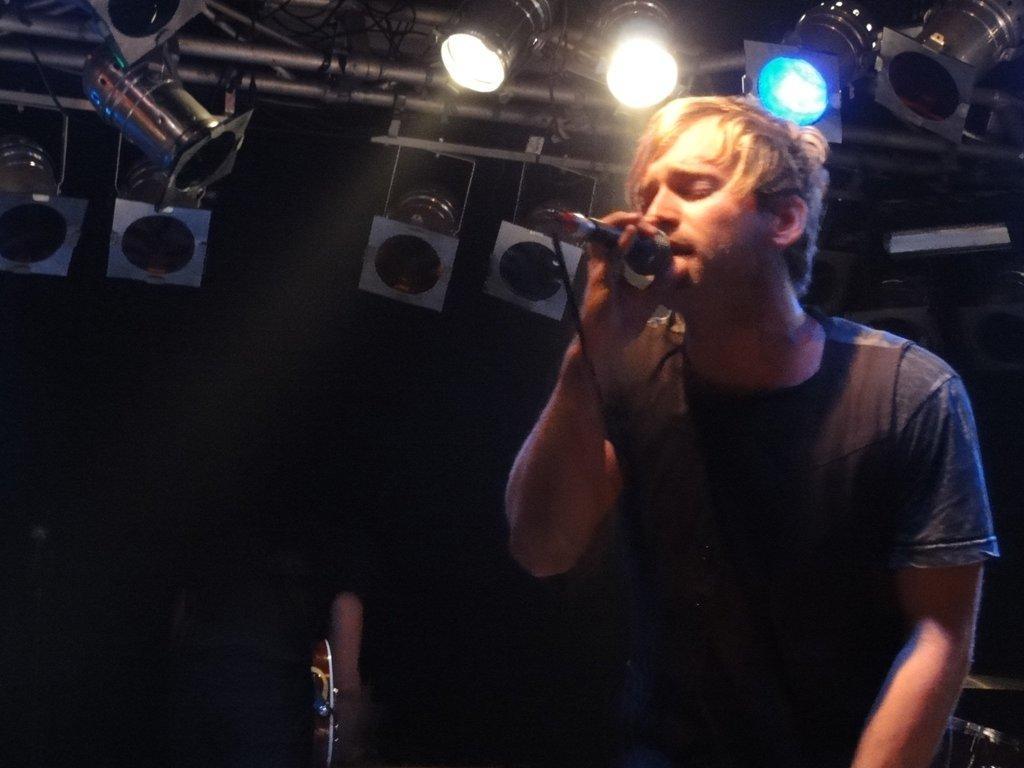In one or two sentences, can you explain what this image depicts? In this picture we can see a man holding a mic with his hand. In the background we can see the lights, rods, some objects and it is dark. 